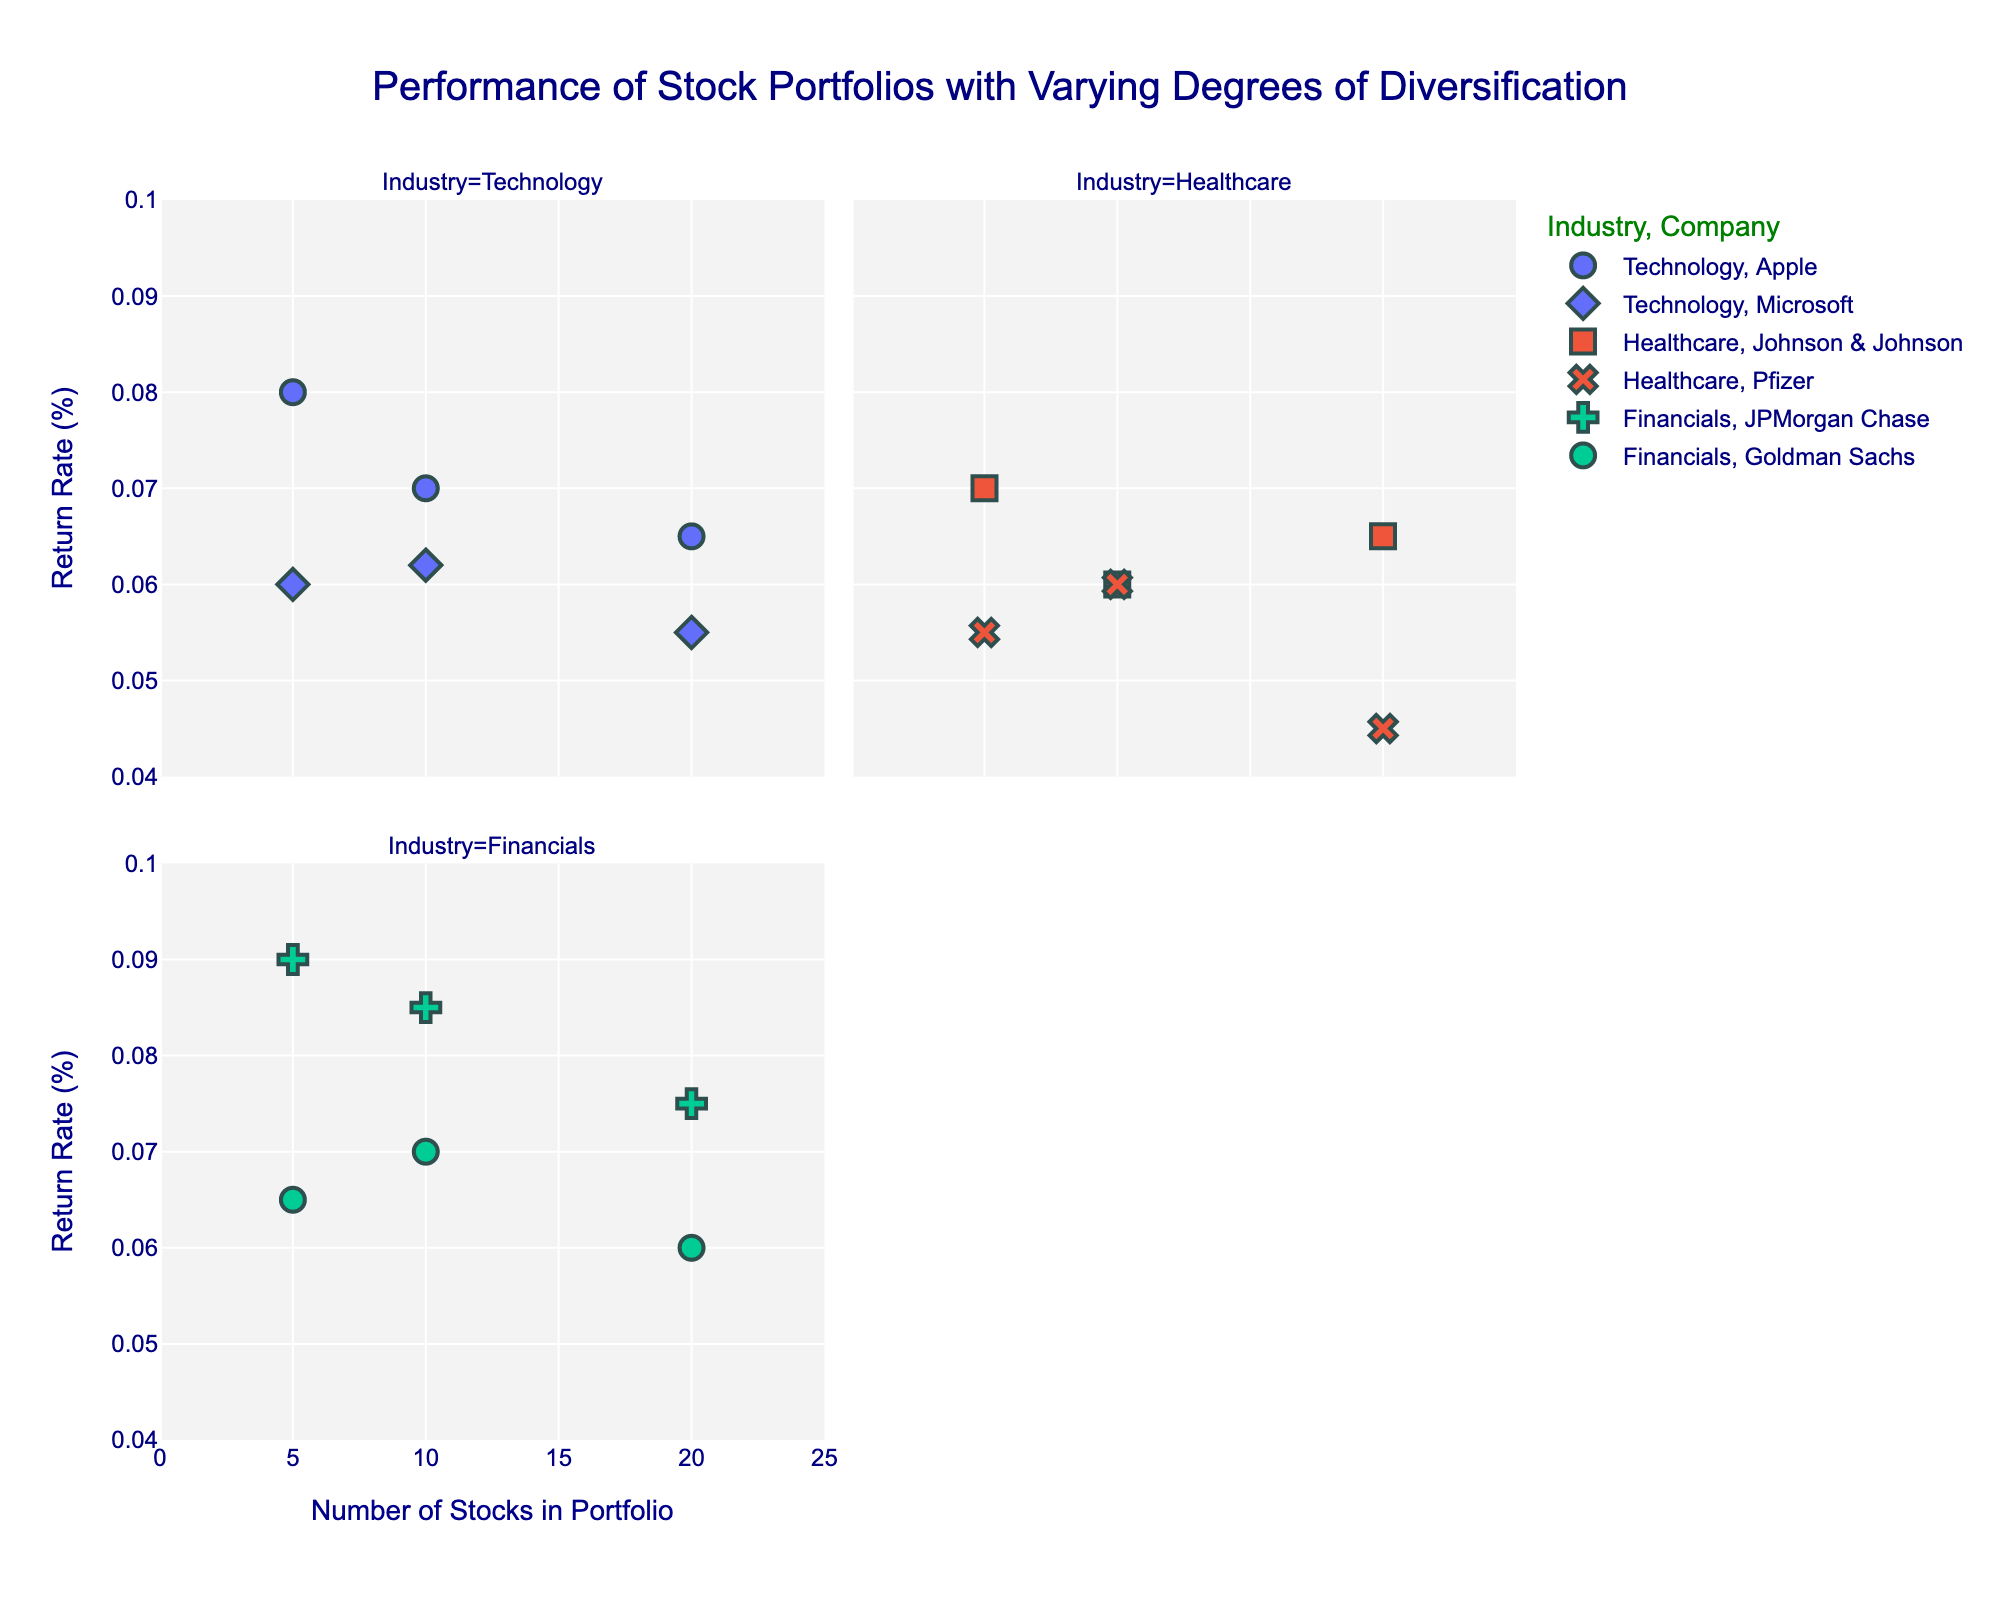What is the title of the plot? The title is located at the top center of the plot in a large font size. This helps in quickly identifying the subject of the figure.
Answer: Performance of Stock Portfolios with Varying Degrees of Diversification What are the industries included in the plot? The industries are represented by different colors. You can see the legend on the side of the plot indicating the colors associated with each industry.
Answer: Technology, Healthcare, Financials How does the number of stocks affect the return rate for Apple in Technology? By looking at the scatter plot under the Technology industry and focusing on the symbols representing Apple, observe how the return rates change with varying numbers of stocks. The plot shows dots at different points, with trends indicated by the pattern.
Answer: Decreases Which company in the Financials industry has the highest return rate at 10 stocks in the portfolio? Refer to the facet for the Financials industry, then locate the data points where the number of stocks is 10. Compare the return rates for JPMorgan Chase and Goldman Sachs.
Answer: JPMorgan Chase What is the difference in return rate between Microsoft and Apple for portfolios with 20 stocks in the Technology industry? Go to the Technology industry plot and locate the points for Microsoft and Apple with 20 stocks. Subtract the return rate of Microsoft from the return rate of Apple.
Answer: 0.01 Which company has the lowest return rate in the Healthcare industry for 20 stocks? Examine the Healthcare plot, then find the data points where the number of stocks is 20 for both Johnson & Johnson and Pfizer. Compare the return rates.
Answer: Pfizer In which industry does increasing the number of stocks seem to generally decrease the return rate? Compare the trends in each industry from the least number of stocks to the highest. Observe which industries show a general downward trend.
Answer: Technology What's the average return rate of portfolios with 5 stocks in the Financials industry? Identify the data points for the Financials industry where the number of stocks is 5. Sum the return rates for JPMorgan Chase and Goldman Sachs, then divide by 2 (the number of companies).
Answer: 0.0775 